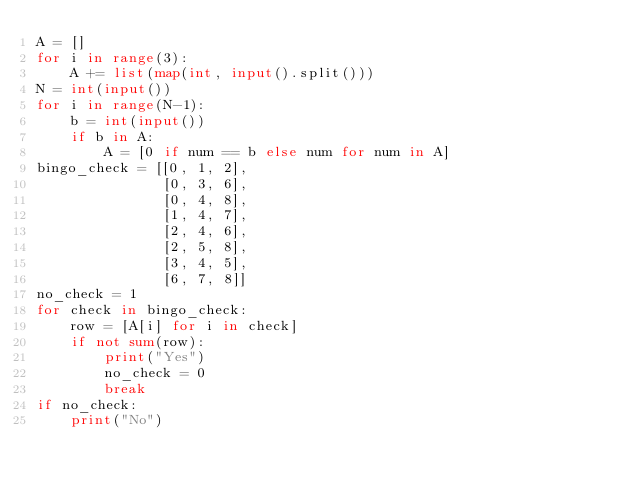Convert code to text. <code><loc_0><loc_0><loc_500><loc_500><_Python_>A = []
for i in range(3):
    A += list(map(int, input().split()))
N = int(input())
for i in range(N-1):
    b = int(input())
    if b in A:
        A = [0 if num == b else num for num in A]
bingo_check = [[0, 1, 2],
               [0, 3, 6],
               [0, 4, 8],
               [1, 4, 7],
               [2, 4, 6],
               [2, 5, 8],
               [3, 4, 5],
               [6, 7, 8]]
no_check = 1
for check in bingo_check:
    row = [A[i] for i in check]
    if not sum(row):
        print("Yes")
        no_check = 0
        break
if no_check:
    print("No")</code> 